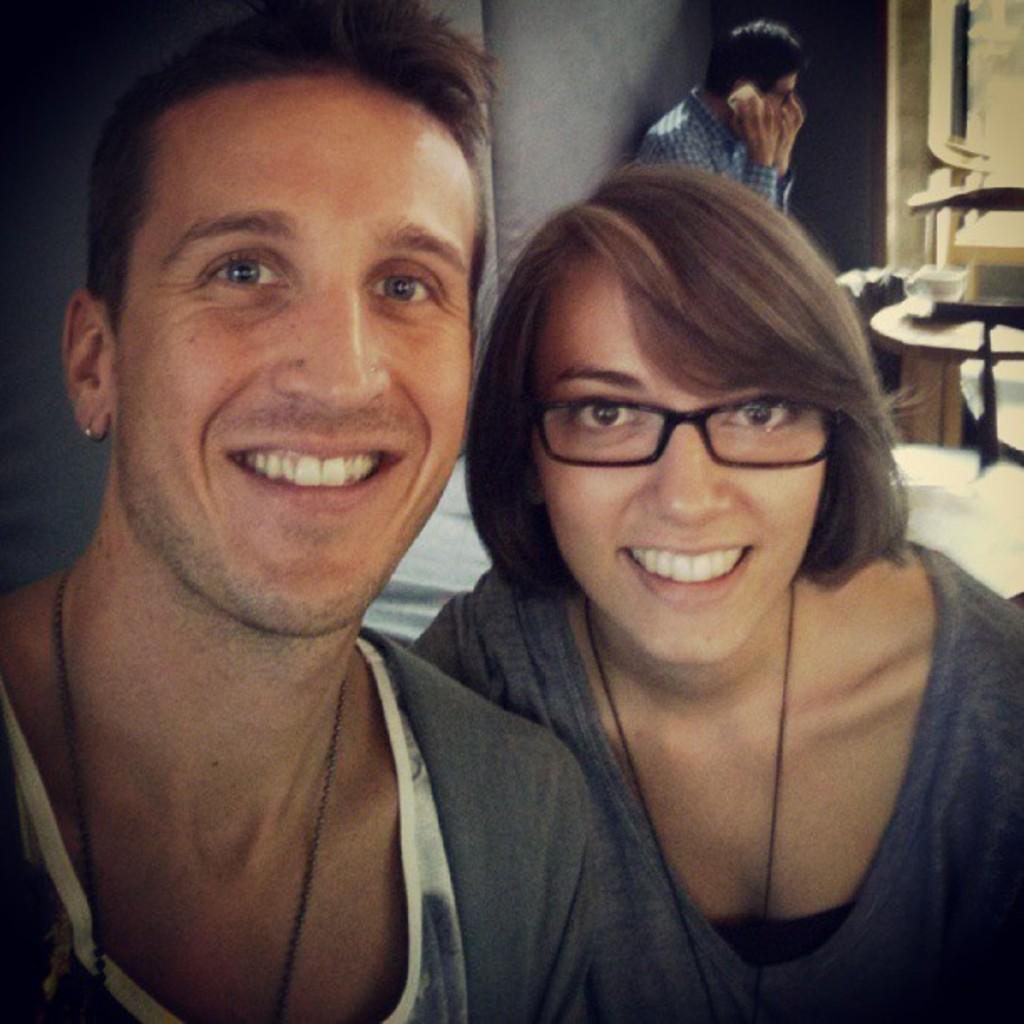Describe this image in one or two sentences. there is a man and woman smiling together behind them the other man sitting and speaking on a mobile phone. 